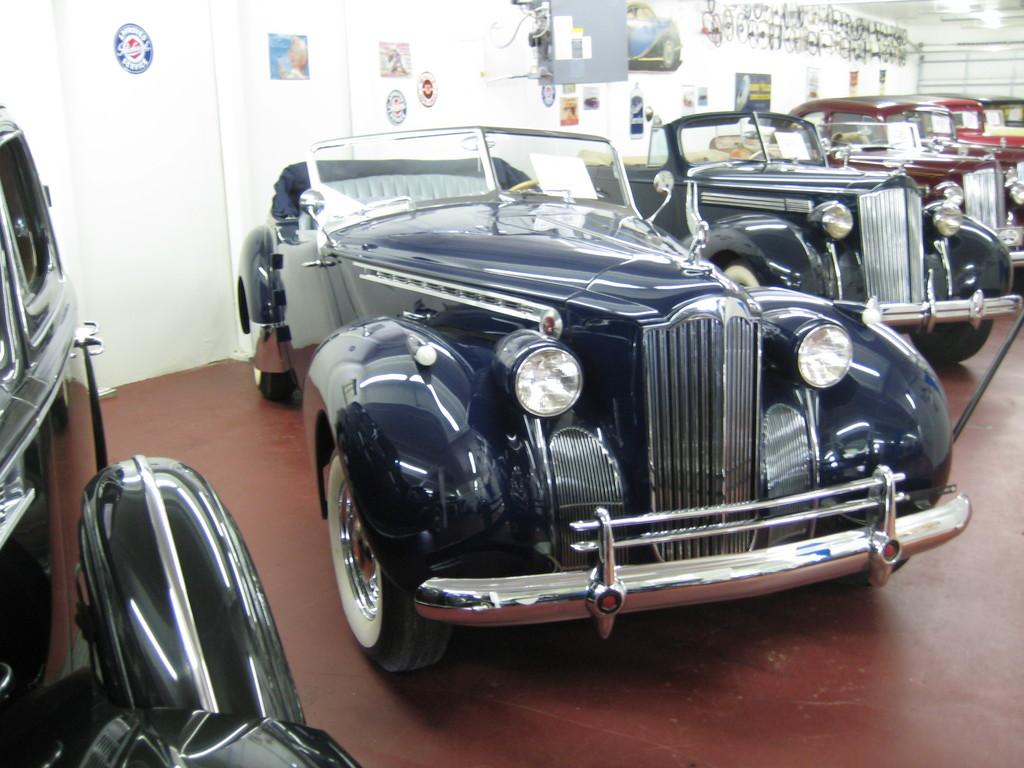What objects are on the floor in the image? There are motor vehicles on the floor in the image. What can be seen on the wall in the background of the image? There are papers pasted on the wall in the background of the image. What type of hair can be seen on the motor vehicles in the image? There is no hair present on the motor vehicles in the image. How does the match light up the papers on the wall in the image? There is no match present in the image, and the papers on the wall are already pasted and not being lit up. 